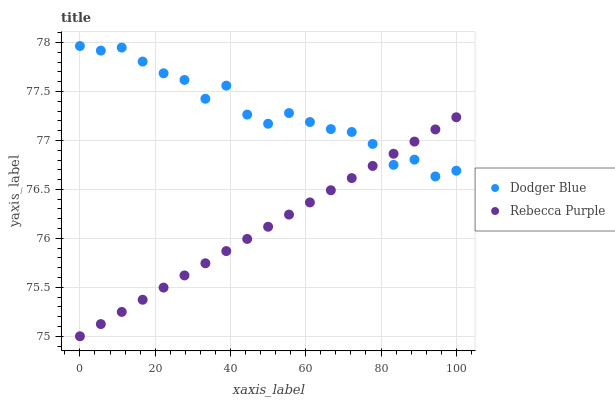Does Rebecca Purple have the minimum area under the curve?
Answer yes or no. Yes. Does Dodger Blue have the maximum area under the curve?
Answer yes or no. Yes. Does Rebecca Purple have the maximum area under the curve?
Answer yes or no. No. Is Rebecca Purple the smoothest?
Answer yes or no. Yes. Is Dodger Blue the roughest?
Answer yes or no. Yes. Is Rebecca Purple the roughest?
Answer yes or no. No. Does Rebecca Purple have the lowest value?
Answer yes or no. Yes. Does Dodger Blue have the highest value?
Answer yes or no. Yes. Does Rebecca Purple have the highest value?
Answer yes or no. No. Does Rebecca Purple intersect Dodger Blue?
Answer yes or no. Yes. Is Rebecca Purple less than Dodger Blue?
Answer yes or no. No. Is Rebecca Purple greater than Dodger Blue?
Answer yes or no. No. 